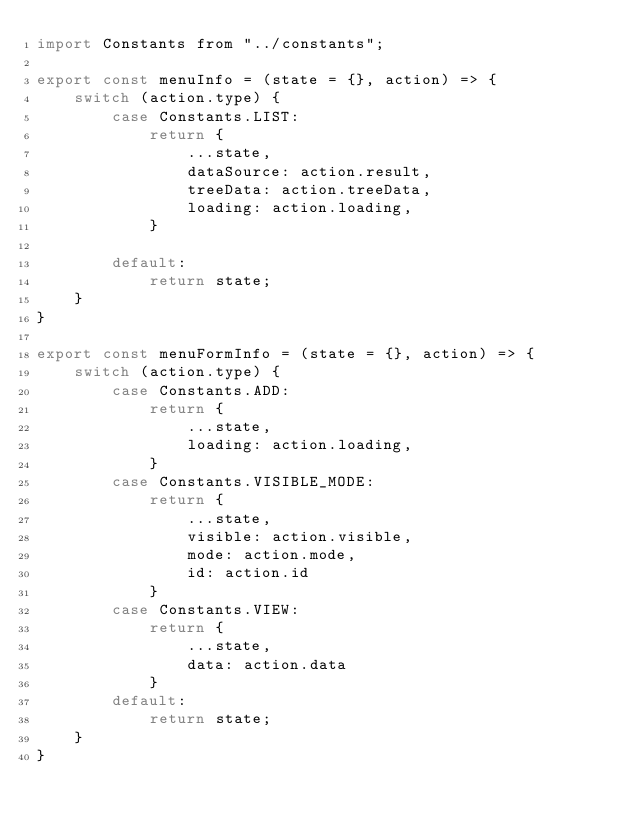Convert code to text. <code><loc_0><loc_0><loc_500><loc_500><_JavaScript_>import Constants from "../constants";

export const menuInfo = (state = {}, action) => {
    switch (action.type) {
        case Constants.LIST:
            return {
                ...state,
                dataSource: action.result,
                treeData: action.treeData,
                loading: action.loading,
            }

        default:
            return state;
    }
}

export const menuFormInfo = (state = {}, action) => {
    switch (action.type) {
        case Constants.ADD:
            return {
                ...state,
                loading: action.loading,
            }
        case Constants.VISIBLE_MODE:
            return {
                ...state,
                visible: action.visible,
                mode: action.mode,
                id: action.id
            }
        case Constants.VIEW:
            return {
                ...state,
                data: action.data
            }
        default:
            return state;
    }
}</code> 